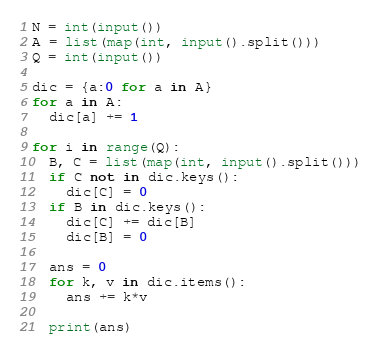Convert code to text. <code><loc_0><loc_0><loc_500><loc_500><_Python_>N = int(input())
A = list(map(int, input().split()))
Q = int(input())

dic = {a:0 for a in A}
for a in A:
  dic[a] += 1

for i in range(Q):
  B, C = list(map(int, input().split()))
  if C not in dic.keys():
    dic[C] = 0
  if B in dic.keys():
    dic[C] += dic[B]
    dic[B] = 0
  
  ans = 0
  for k, v in dic.items():
    ans += k*v
  
  print(ans)</code> 